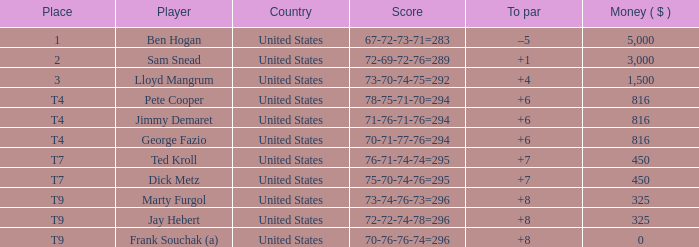Can you parse all the data within this table? {'header': ['Place', 'Player', 'Country', 'Score', 'To par', 'Money ( $ )'], 'rows': [['1', 'Ben Hogan', 'United States', '67-72-73-71=283', '–5', '5,000'], ['2', 'Sam Snead', 'United States', '72-69-72-76=289', '+1', '3,000'], ['3', 'Lloyd Mangrum', 'United States', '73-70-74-75=292', '+4', '1,500'], ['T4', 'Pete Cooper', 'United States', '78-75-71-70=294', '+6', '816'], ['T4', 'Jimmy Demaret', 'United States', '71-76-71-76=294', '+6', '816'], ['T4', 'George Fazio', 'United States', '70-71-77-76=294', '+6', '816'], ['T7', 'Ted Kroll', 'United States', '76-71-74-74=295', '+7', '450'], ['T7', 'Dick Metz', 'United States', '75-70-74-76=295', '+7', '450'], ['T9', 'Marty Furgol', 'United States', '73-74-76-73=296', '+8', '325'], ['T9', 'Jay Hebert', 'United States', '72-72-74-78=296', '+8', '325'], ['T9', 'Frank Souchak (a)', 'United States', '70-76-76-74=296', '+8', '0']]} How much was paid to the player whose score was 70-71-77-76=294? 816.0. 